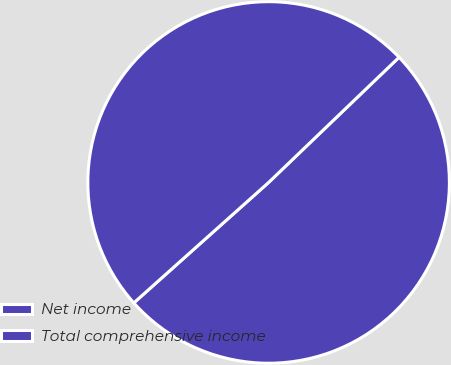Convert chart to OTSL. <chart><loc_0><loc_0><loc_500><loc_500><pie_chart><fcel>Net income<fcel>Total comprehensive income<nl><fcel>50.57%<fcel>49.43%<nl></chart> 